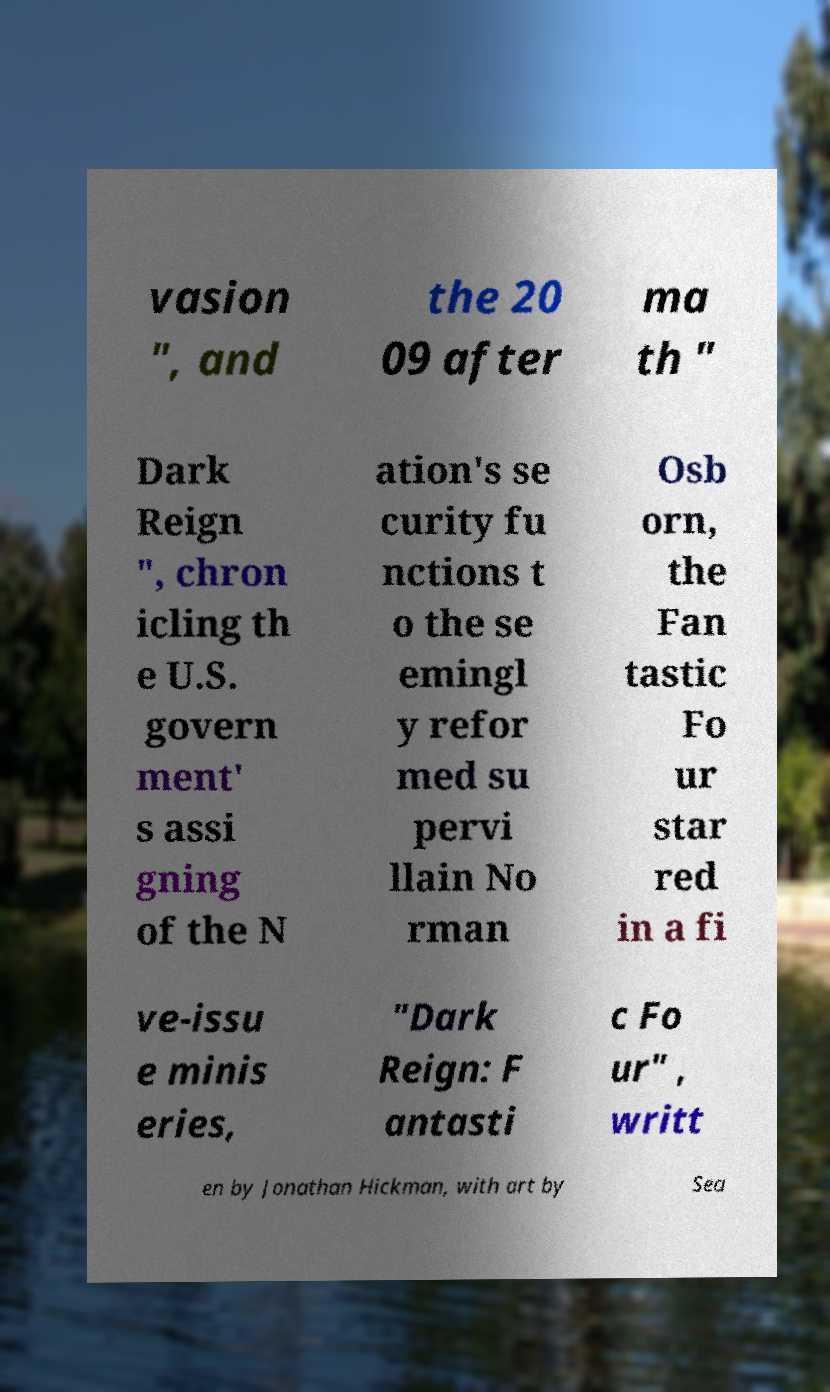What messages or text are displayed in this image? I need them in a readable, typed format. vasion ", and the 20 09 after ma th " Dark Reign ", chron icling th e U.S. govern ment' s assi gning of the N ation's se curity fu nctions t o the se emingl y refor med su pervi llain No rman Osb orn, the Fan tastic Fo ur star red in a fi ve-issu e minis eries, "Dark Reign: F antasti c Fo ur" , writt en by Jonathan Hickman, with art by Sea 